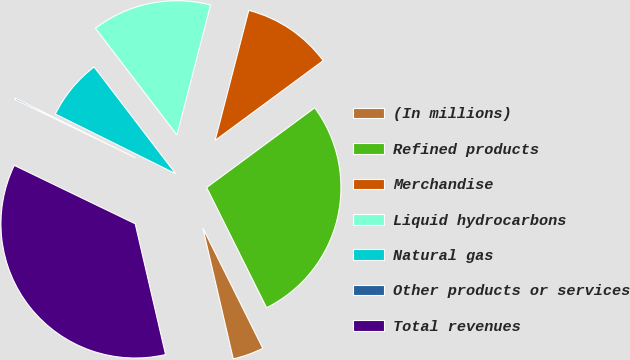Convert chart. <chart><loc_0><loc_0><loc_500><loc_500><pie_chart><fcel>(In millions)<fcel>Refined products<fcel>Merchandise<fcel>Liquid hydrocarbons<fcel>Natural gas<fcel>Other products or services<fcel>Total revenues<nl><fcel>3.73%<fcel>27.75%<fcel>10.85%<fcel>14.41%<fcel>7.29%<fcel>0.17%<fcel>35.78%<nl></chart> 